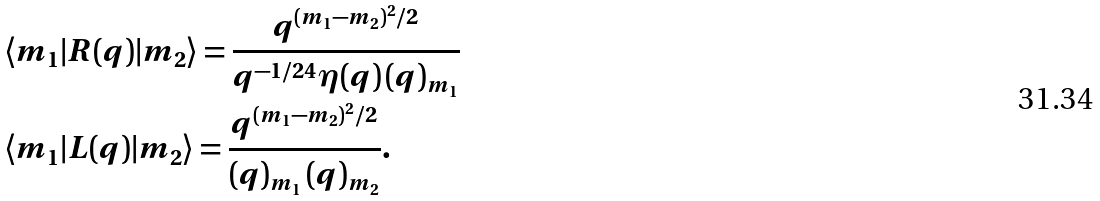Convert formula to latex. <formula><loc_0><loc_0><loc_500><loc_500>& \langle m _ { 1 } | R ( q ) | m _ { 2 } \rangle = \frac { q ^ { ( m _ { 1 } - m _ { 2 } ) ^ { 2 } / 2 } } { q ^ { - 1 / 2 4 } \eta ( q ) \, ( q ) _ { m _ { 1 } } } \\ & \langle m _ { 1 } | L ( q ) | m _ { 2 } \rangle = \frac { q ^ { ( m _ { 1 } - m _ { 2 } ) ^ { 2 } / 2 } } { ( q ) _ { m _ { 1 } } \, ( q ) _ { m _ { 2 } } } .</formula> 